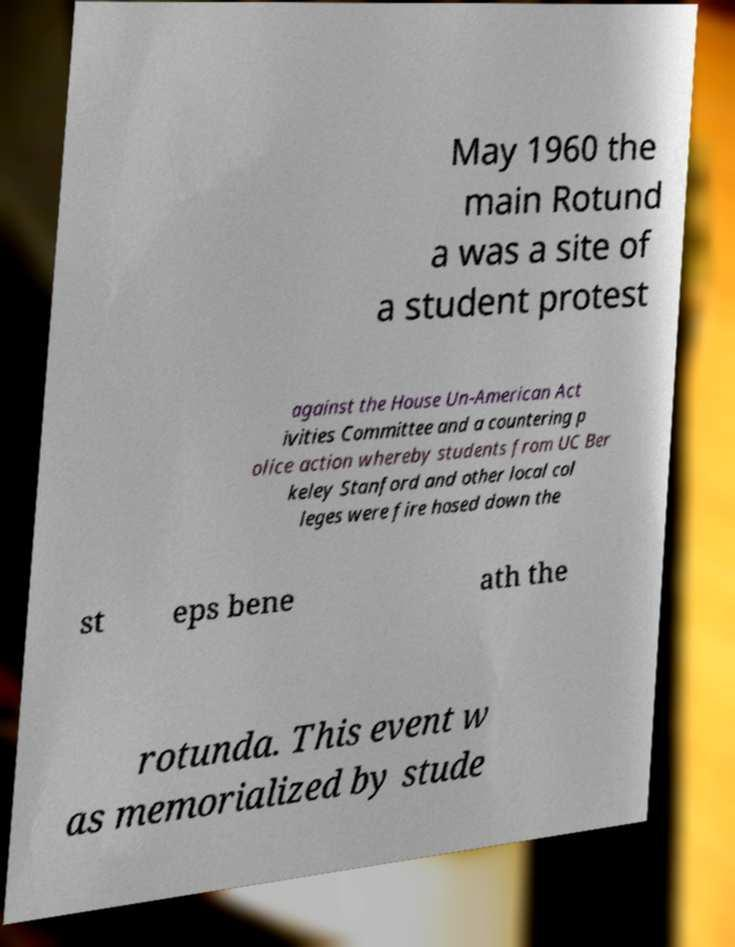Can you accurately transcribe the text from the provided image for me? May 1960 the main Rotund a was a site of a student protest against the House Un-American Act ivities Committee and a countering p olice action whereby students from UC Ber keley Stanford and other local col leges were fire hosed down the st eps bene ath the rotunda. This event w as memorialized by stude 